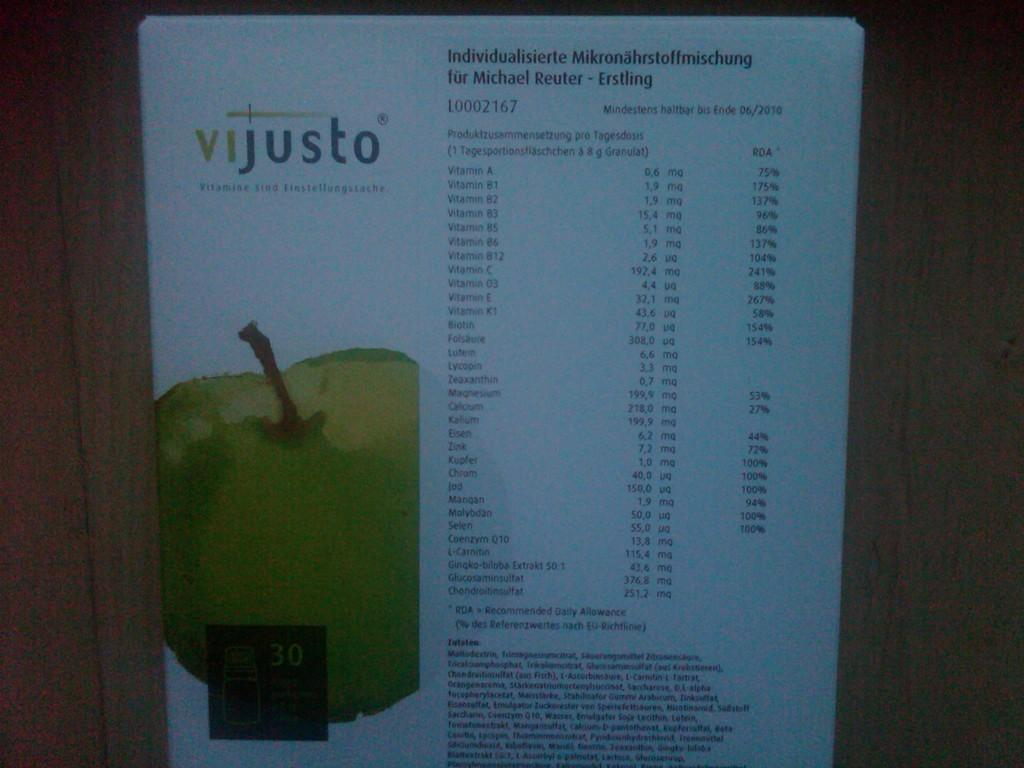Provide a one-sentence caption for the provided image. A picture of an apple under the words Vijusto. 